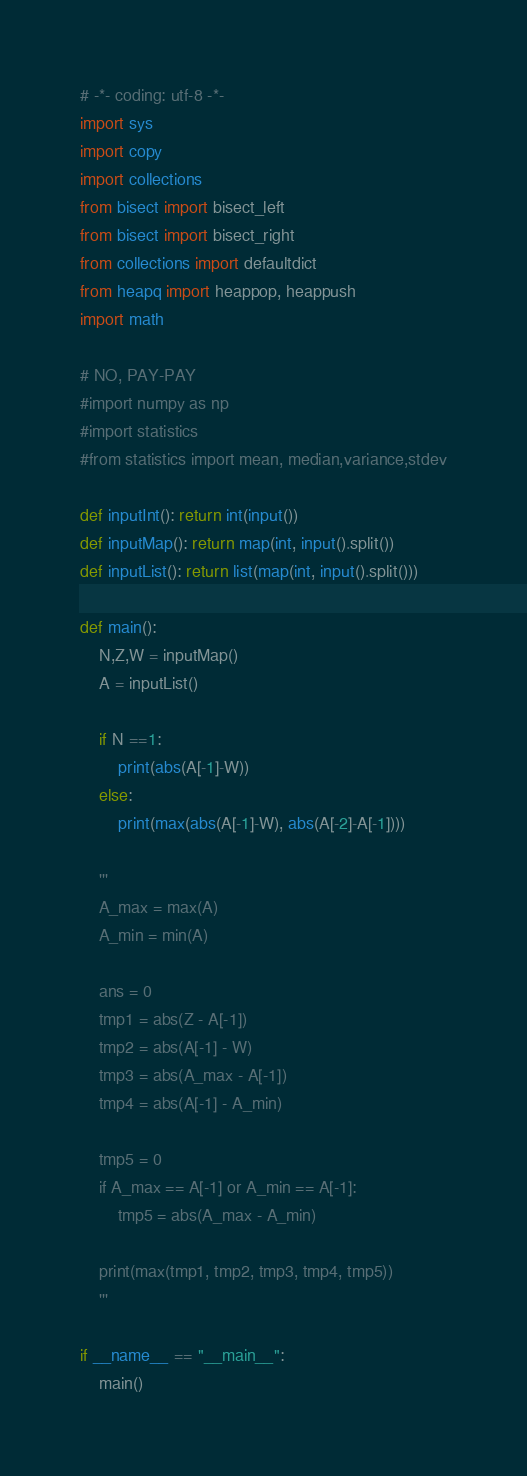<code> <loc_0><loc_0><loc_500><loc_500><_Python_># -*- coding: utf-8 -*-
import sys
import copy
import collections
from bisect import bisect_left
from bisect import bisect_right
from collections import defaultdict
from heapq import heappop, heappush
import math

# NO, PAY-PAY
#import numpy as np
#import statistics
#from statistics import mean, median,variance,stdev

def inputInt(): return int(input())
def inputMap(): return map(int, input().split())
def inputList(): return list(map(int, input().split()))
 
def main():
    N,Z,W = inputMap()
    A = inputList()
    
    if N ==1:
        print(abs(A[-1]-W))
    else:
        print(max(abs(A[-1]-W), abs(A[-2]-A[-1])))
    
    '''
    A_max = max(A)
    A_min = min(A)
    
    ans = 0
    tmp1 = abs(Z - A[-1])
    tmp2 = abs(A[-1] - W)
    tmp3 = abs(A_max - A[-1])
    tmp4 = abs(A[-1] - A_min)
    
    tmp5 = 0
    if A_max == A[-1] or A_min == A[-1]:
        tmp5 = abs(A_max - A_min)
    
    print(max(tmp1, tmp2, tmp3, tmp4, tmp5))
    '''
            	
if __name__ == "__main__":
	main()
</code> 